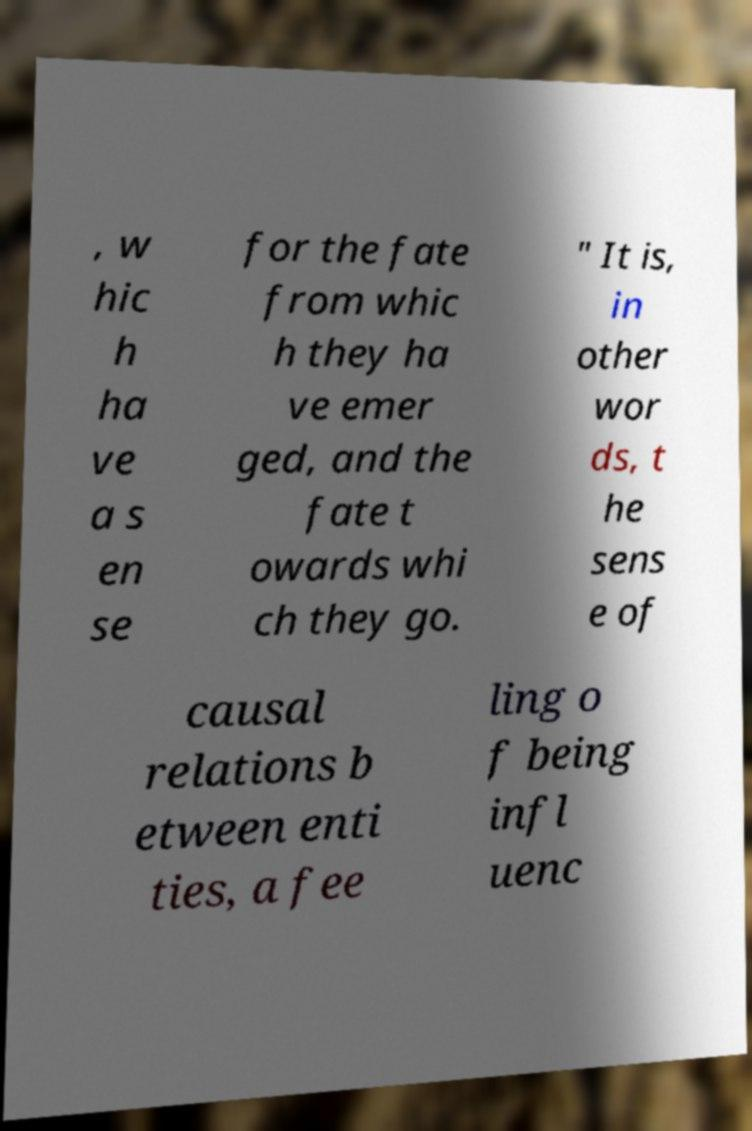Could you assist in decoding the text presented in this image and type it out clearly? , w hic h ha ve a s en se for the fate from whic h they ha ve emer ged, and the fate t owards whi ch they go. " It is, in other wor ds, t he sens e of causal relations b etween enti ties, a fee ling o f being infl uenc 